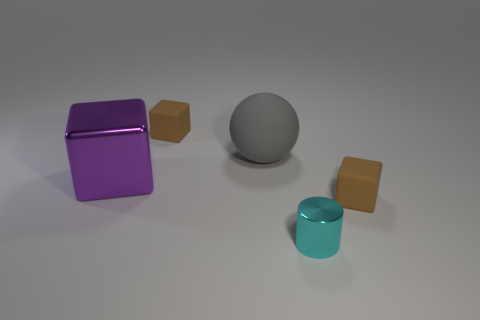Add 3 small gray shiny cylinders. How many objects exist? 8 Subtract all cubes. How many objects are left? 2 Subtract 0 red cylinders. How many objects are left? 5 Subtract all big red objects. Subtract all tiny cyan cylinders. How many objects are left? 4 Add 1 small cubes. How many small cubes are left? 3 Add 1 cylinders. How many cylinders exist? 2 